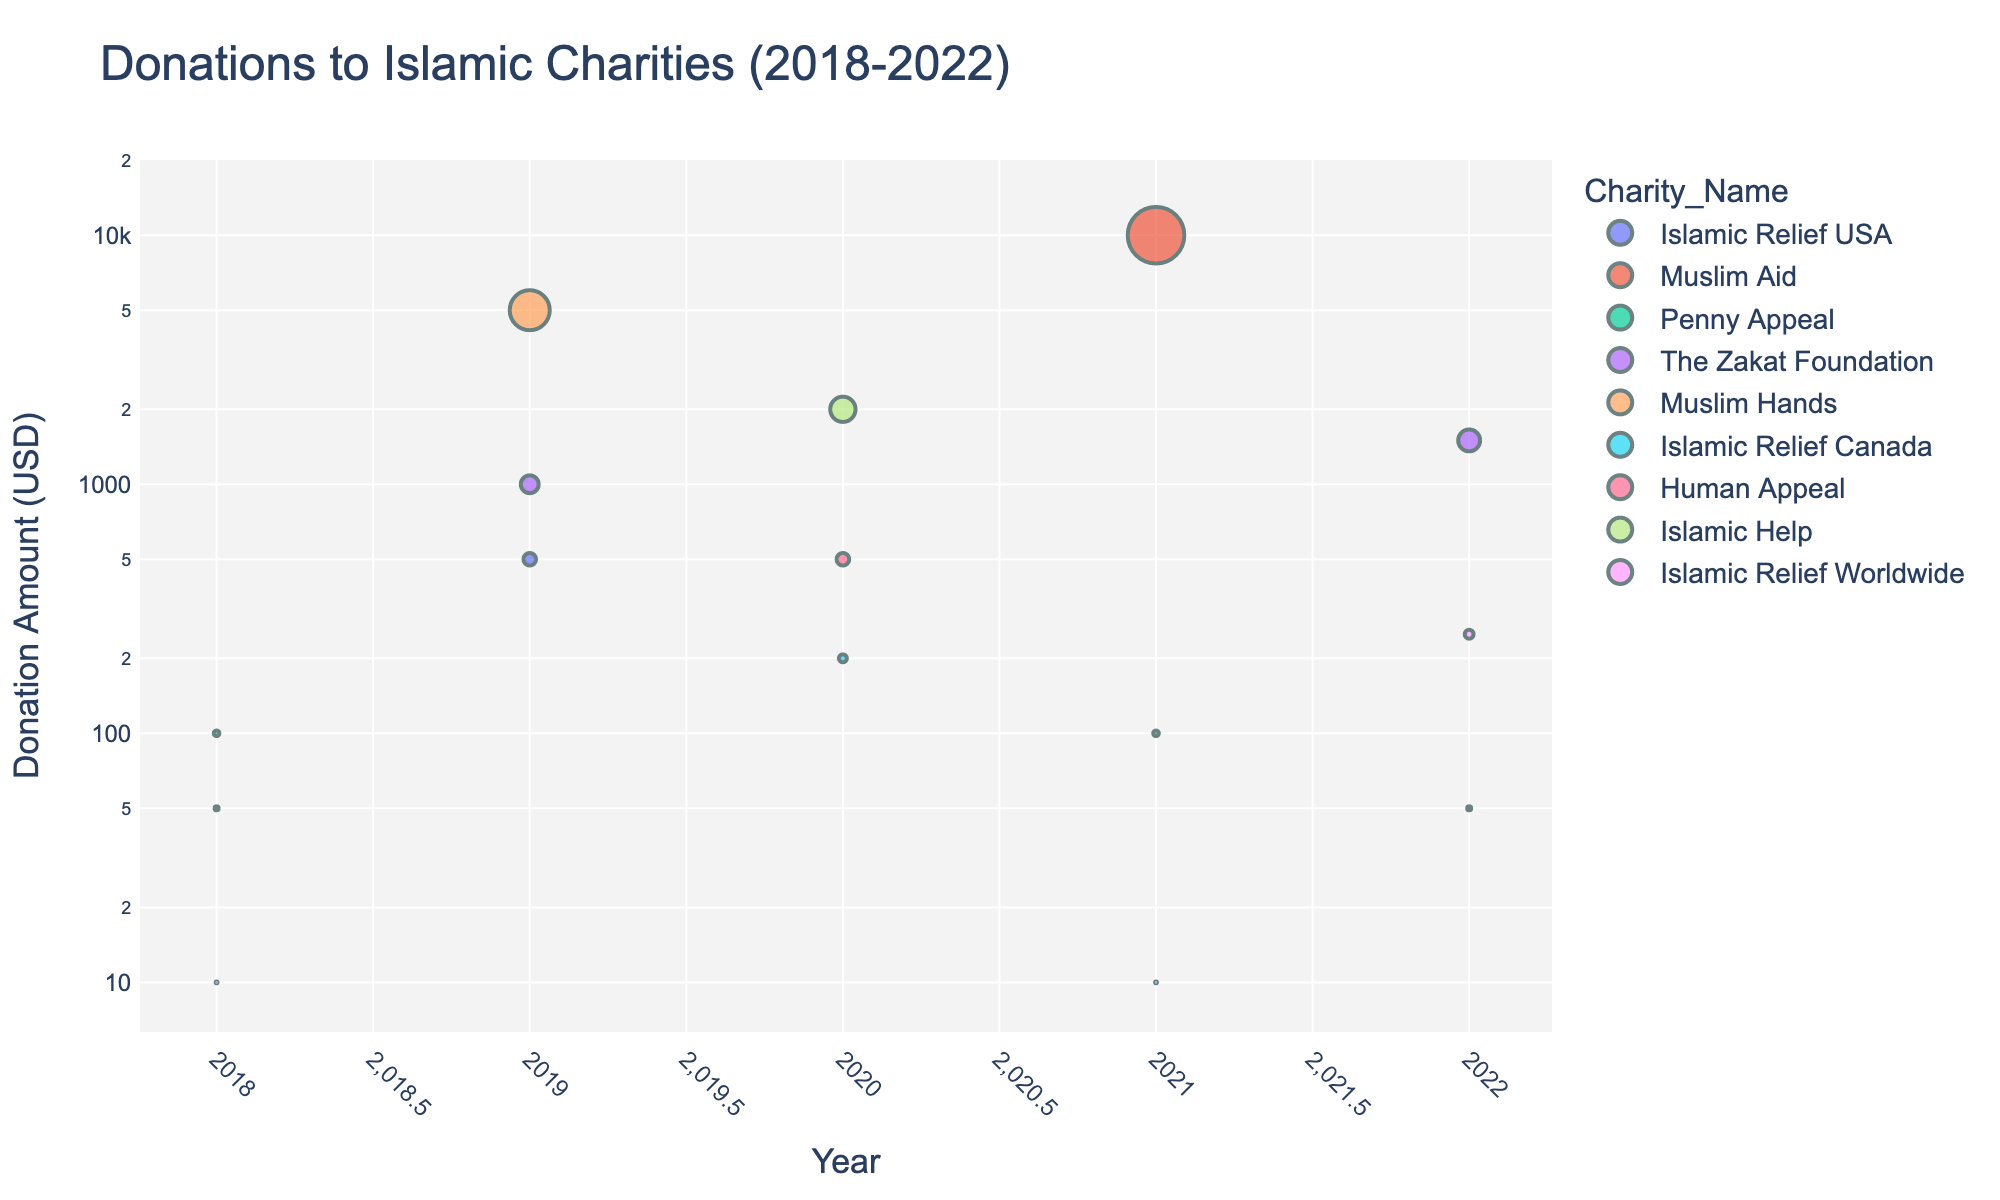What's the highest donation amount seen in the plot? The highest donation amount can be identified by looking for the data point positioned at the top of the log-scaled y-axis. This represents the maximum donation amount.
Answer: 10000 Which charity received the smallest donation in 2022? To find this, look at the year 2022 on the x-axis and find the data points for that year. The smallest donation amount among these data points is the one closest to the bottom of the y-axis.
Answer: Human Appeal What is the average donation received by Islamic Relief USA over the years? Identify the donations for each year attributed to Islamic Relief USA (2018: 10, 2019: 500, 2020: 200, 2021: 10), then calculate the average by summing these values and dividing by the number of years. (10 + 500 + 200 + 10) / 4 = 720 / 4 = 180
Answer: 180 How does the donation amount trend for Muslim Aid from 2018 to 2021? Look at the donation data points for Muslim Aid across 2018, 2019, and 2021. Compare their vertical positions (heights) on the log-scaled y-axis to understand the trend. Muslim Aid's donations are 50 (2018), absent in 2019, and 10000 (2021), showing a substantial increase.
Answer: Significantly increased Which two charities had the highest donations in 2020? Examine the data points for 2020 and identify the two highest points on the log-scaled y-axis; the charities associated with these points are the answers.
Answer: Islamic Help and Human Appeal Was there a significant change in donation amounts to The Zakat Foundation from 2019 to 2022? Locate The Zakat Foundation's donations in 2019 and 2022 and compare their values. In 2019, it's 1000, and in 2022, it's 1500; look at the increment to determine significance.
Answer: Yes Which year had the highest total donations across all Islamic charities in the dataset? Sum the donations for each year and compare the totals. The year with the highest sum is the answer. Calculations: 
2018: 10 + 50 + 100 = 160 
2019: 500 + 1000 + 5000 = 6500 
2020: 200 + 500 + 2000 = 2700 
2021: 10 + 100 + 10000 = 10110 
2022: 50 + 250 + 1500 = 1800 
The year 2021 has the highest total of 10110.
Answer: 2021 